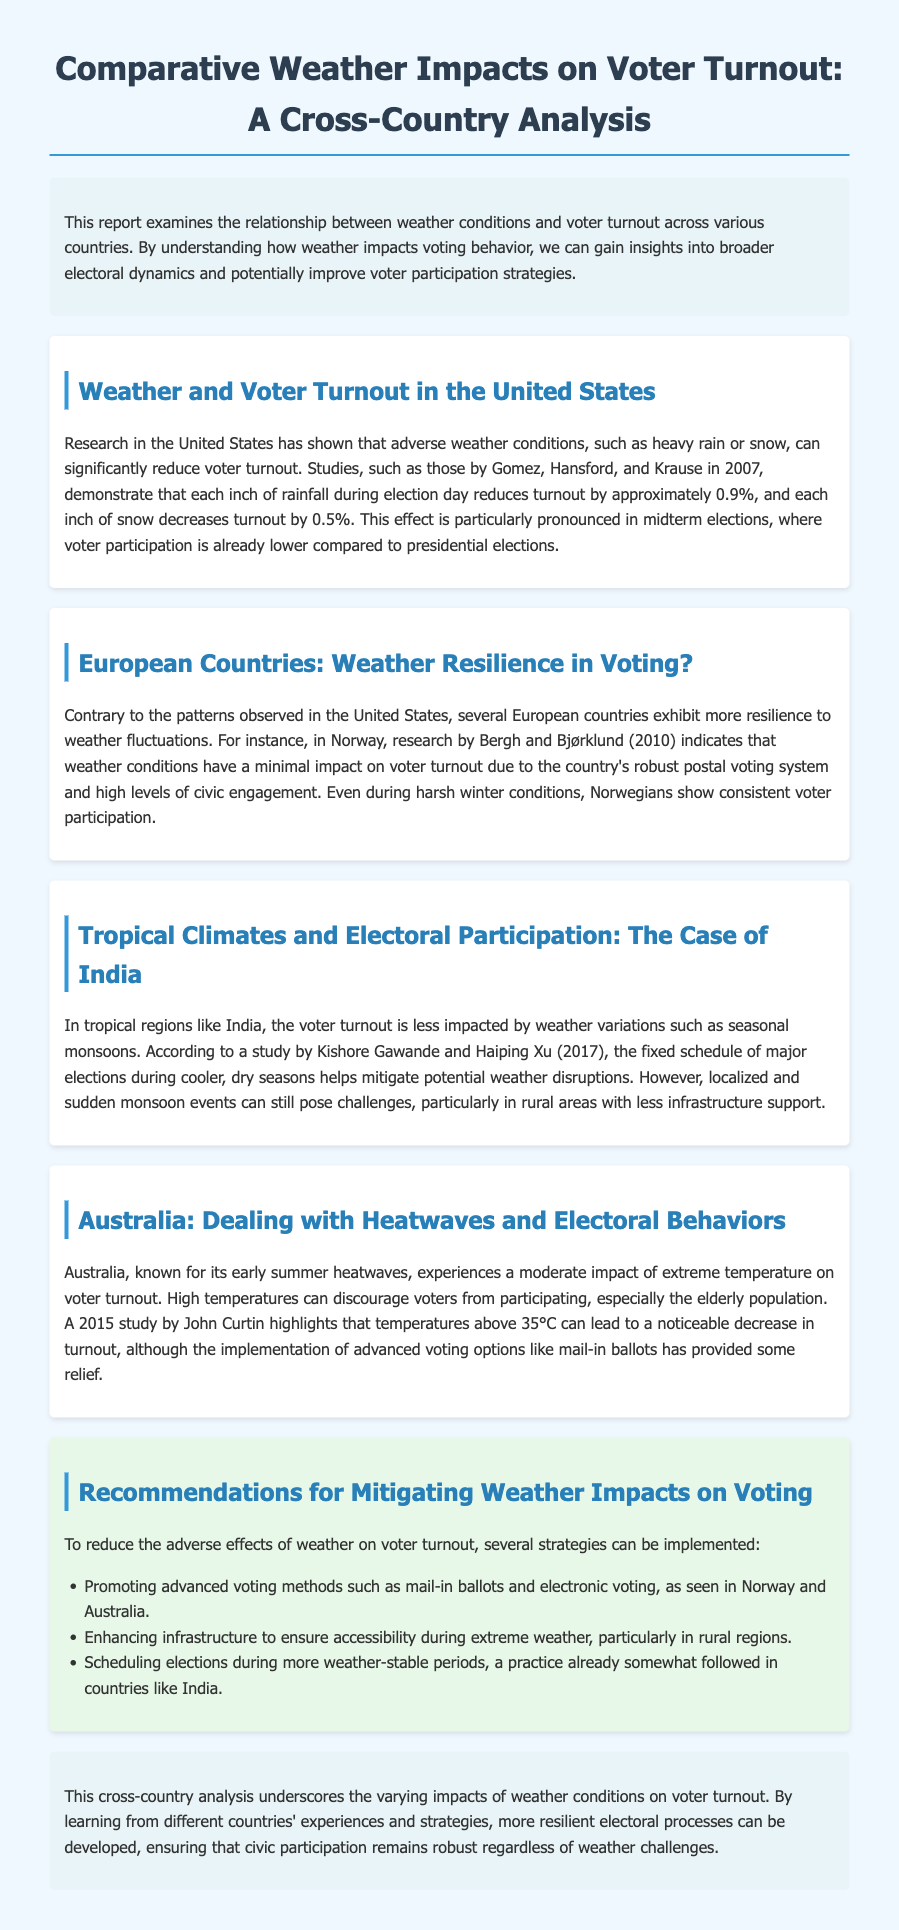What is the title of the report? The title of the report is indicated in the heading of the document.
Answer: Comparative Weather Impacts on Voter Turnout: A Cross-Country Analysis Who conducted the research about weather impacts in the United States? The document mentions specific researchers who studied this phenomenon in the U.S.
Answer: Gomez, Hansford, and Krause How much does each inch of rainfall reduce voter turnout in the U.S.? The report specifies a numerical impact of rainfall on voter turnout in the United States.
Answer: 0.9% Which country shows resilience to weather fluctuations in voter turnout? The document describes a country that maintains consistent voter participation despite weather conditions.
Answer: Norway What year did the study about Australia and heatwaves take place? The report references a study related to heatwaves and Australian voter turnout, noting the publication year.
Answer: 2015 What voting method is recommended to mitigate weather impacts? The report suggests a strategy to enhance voter participation during adverse weather.
Answer: Mail-in ballots How do seasonal monsoons affect voter turnout in India? The document discusses weather impacts in India, specifically addressing seasonal variations.
Answer: Less impacted Which electoral challenge is mentioned for rural areas in India? The report highlights specific difficulties faced by rural regions during weather events.
Answer: Less infrastructure support 